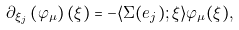<formula> <loc_0><loc_0><loc_500><loc_500>\partial _ { \xi _ { j } } \left ( \varphi _ { \mu } \right ) ( \xi ) = - \langle \Sigma ( e _ { j } ) ; \xi \rangle \varphi _ { \mu } ( \xi ) ,</formula> 